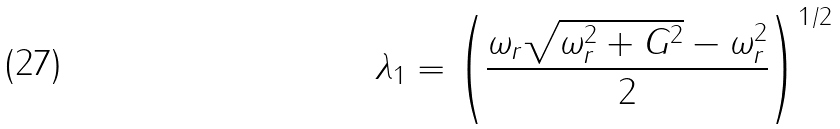Convert formula to latex. <formula><loc_0><loc_0><loc_500><loc_500>\lambda _ { 1 } = \left ( \frac { \omega _ { r } \sqrt { \omega _ { r } ^ { 2 } + G ^ { 2 } } - \omega _ { r } ^ { 2 } } { 2 } \right ) ^ { 1 / 2 }</formula> 